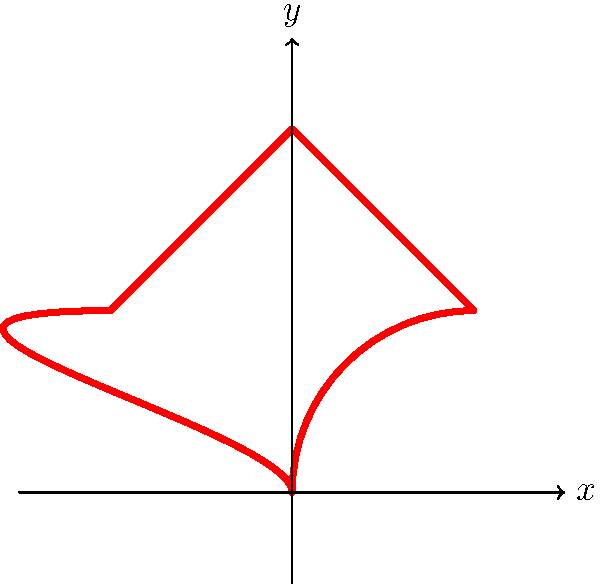Your local cinema is offering heart-shaped movie tickets for a romantic comedy festival. The shape of the ticket is represented by the heart in the coordinate plane above. What is the order of the symmetry group of this heart-shaped ticket? Let's analyze the symmetries of the heart-shaped ticket step by step:

1. Rotational symmetry:
   - The heart shape does not have any rotational symmetry other than the identity (360° rotation).

2. Reflection symmetry:
   - The heart shape has one line of reflection symmetry along the y-axis.

3. Counting the symmetries:
   - Identity transformation (always present in any symmetry group)
   - Reflection about the y-axis

Therefore, the symmetry group of the heart-shaped ticket consists of two elements:
1. The identity transformation
2. Reflection about the y-axis

In group theory, the order of a group is the number of elements in the group. Since we have identified two distinct symmetry operations, the order of the symmetry group is 2.

This group is isomorphic to the cyclic group $C_2$ or the reflection group $D_1$, both of which have order 2.
Answer: 2 